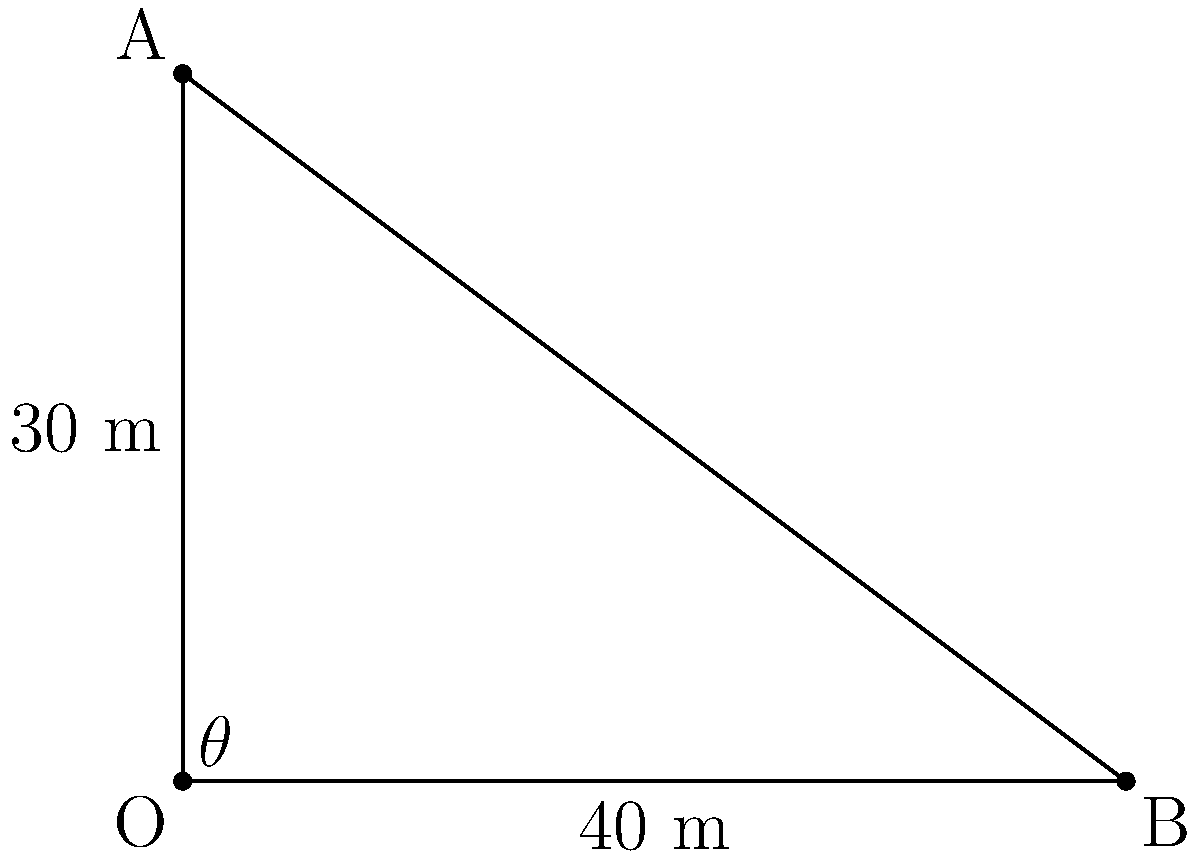A football is kicked from point O and reaches a maximum height of 30 meters at point A, directly above the kicker. The ball then travels a horizontal distance of 40 meters before landing at point B. What is the angle $\theta$ of the ball's initial trajectory from the ground? To solve this problem, we'll use the tangent function from trigonometry. The tangent of an angle in a right triangle is the ratio of the opposite side to the adjacent side.

1) In this case, we have a right triangle OAB, where:
   - The opposite side (OA) is 30 meters (the maximum height)
   - The adjacent side (OB) is 40 meters (the horizontal distance)

2) The tangent of angle $\theta$ is:

   $\tan(\theta) = \frac{\text{opposite}}{\text{adjacent}} = \frac{30}{40} = 0.75$

3) To find $\theta$, we need to use the inverse tangent (arctan or $\tan^{-1}$):

   $\theta = \tan^{-1}(0.75)$

4) Using a calculator or trigonometric tables:

   $\theta \approx 36.87°$

Therefore, the angle of the ball's initial trajectory from the ground is approximately 36.87°.
Answer: $36.87°$ 